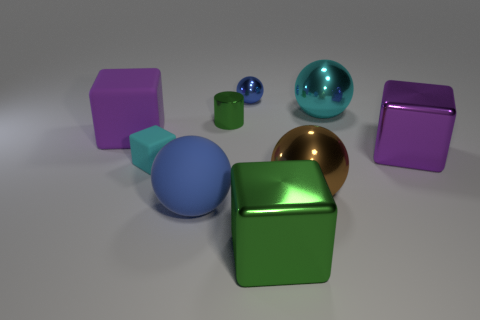What material is the ball that is the same color as the tiny rubber object?
Keep it short and to the point. Metal. What is the cyan block made of?
Give a very brief answer. Rubber. What number of things are either cubes right of the large cyan metal ball or large metal cubes that are in front of the tiny cyan object?
Provide a succinct answer. 2. Do the tiny rubber thing and the small object that is behind the large cyan ball have the same shape?
Offer a very short reply. No. Are there fewer matte cubes to the left of the small blue metal object than cyan metal spheres that are to the left of the tiny green cylinder?
Keep it short and to the point. No. There is a green object that is the same shape as the tiny cyan object; what material is it?
Give a very brief answer. Metal. Is there any other thing that has the same material as the big green object?
Keep it short and to the point. Yes. Is the tiny block the same color as the shiny cylinder?
Ensure brevity in your answer.  No. What shape is the cyan thing that is made of the same material as the large blue ball?
Offer a terse response. Cube. What number of other shiny things have the same shape as the big blue object?
Your answer should be compact. 3. 